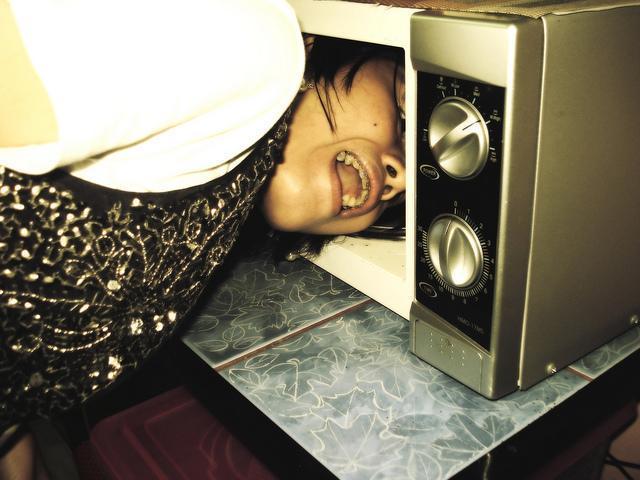How many eyes are in the photo?
Give a very brief answer. 1. How many cars are driving in the opposite direction of the street car?
Give a very brief answer. 0. 